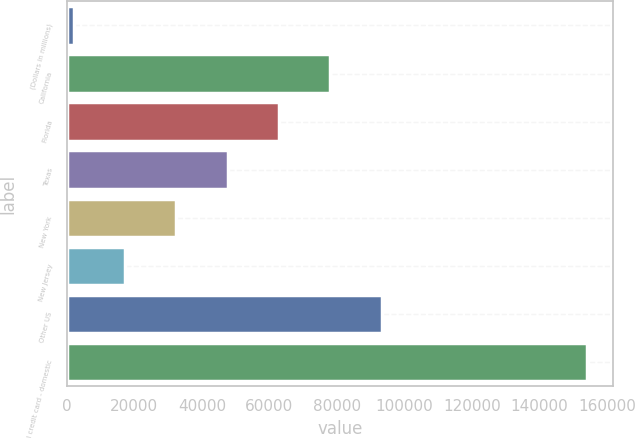Convert chart to OTSL. <chart><loc_0><loc_0><loc_500><loc_500><bar_chart><fcel>(Dollars in millions)<fcel>California<fcel>Florida<fcel>Texas<fcel>New York<fcel>New Jersey<fcel>Other US<fcel>Total credit card - domestic<nl><fcel>2008<fcel>78079.5<fcel>62865.2<fcel>47650.9<fcel>32436.6<fcel>17222.3<fcel>93293.8<fcel>154151<nl></chart> 